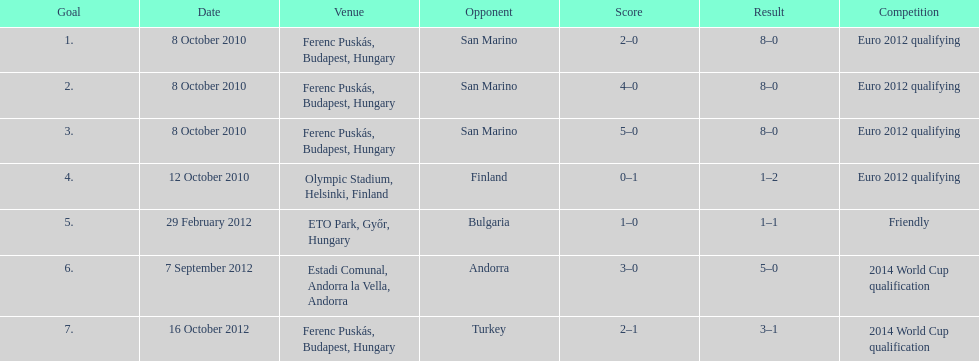How many consecutive games were goals were against san marino? 3. Can you parse all the data within this table? {'header': ['Goal', 'Date', 'Venue', 'Opponent', 'Score', 'Result', 'Competition'], 'rows': [['1.', '8 October 2010', 'Ferenc Puskás, Budapest, Hungary', 'San Marino', '2–0', '8–0', 'Euro 2012 qualifying'], ['2.', '8 October 2010', 'Ferenc Puskás, Budapest, Hungary', 'San Marino', '4–0', '8–0', 'Euro 2012 qualifying'], ['3.', '8 October 2010', 'Ferenc Puskás, Budapest, Hungary', 'San Marino', '5–0', '8–0', 'Euro 2012 qualifying'], ['4.', '12 October 2010', 'Olympic Stadium, Helsinki, Finland', 'Finland', '0–1', '1–2', 'Euro 2012 qualifying'], ['5.', '29 February 2012', 'ETO Park, Győr, Hungary', 'Bulgaria', '1–0', '1–1', 'Friendly'], ['6.', '7 September 2012', 'Estadi Comunal, Andorra la Vella, Andorra', 'Andorra', '3–0', '5–0', '2014 World Cup qualification'], ['7.', '16 October 2012', 'Ferenc Puskás, Budapest, Hungary', 'Turkey', '2–1', '3–1', '2014 World Cup qualification']]} 